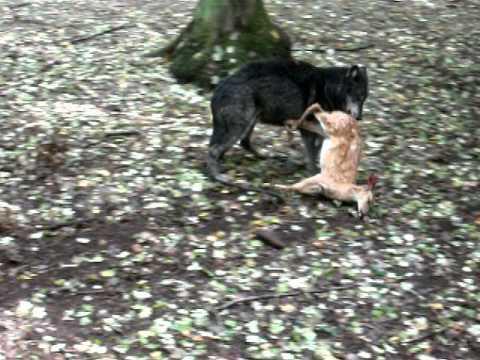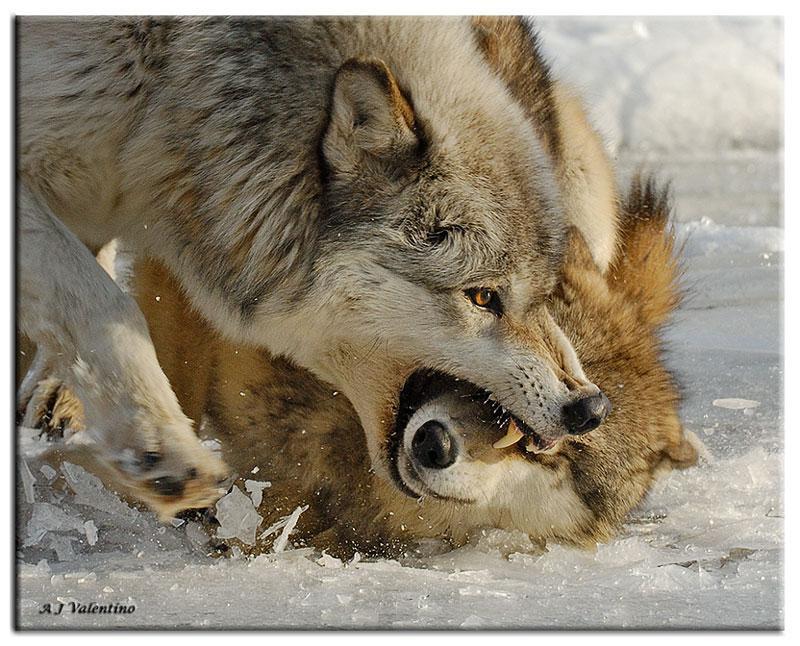The first image is the image on the left, the second image is the image on the right. Given the left and right images, does the statement "One image shows at least three wolves in a confrontational scene, with the one at the center baring its fangs with a wide open mouth, and the other image shows a wolf jumping on another wolf." hold true? Answer yes or no. No. The first image is the image on the left, the second image is the image on the right. For the images shown, is this caption "In at least one image, there are three wolves on snow with at least one with an open angry mouth." true? Answer yes or no. No. 